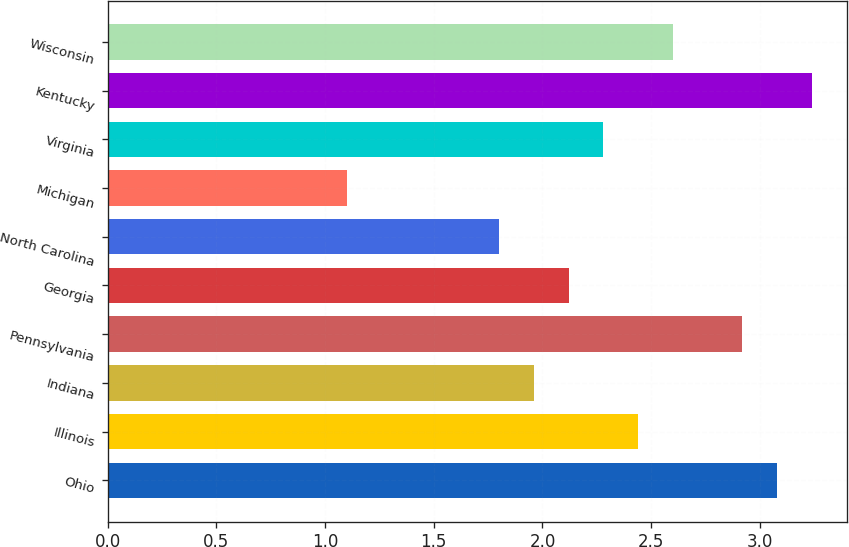<chart> <loc_0><loc_0><loc_500><loc_500><bar_chart><fcel>Ohio<fcel>Illinois<fcel>Indiana<fcel>Pennsylvania<fcel>Georgia<fcel>North Carolina<fcel>Michigan<fcel>Virginia<fcel>Kentucky<fcel>Wisconsin<nl><fcel>3.08<fcel>2.44<fcel>1.96<fcel>2.92<fcel>2.12<fcel>1.8<fcel>1.1<fcel>2.28<fcel>3.24<fcel>2.6<nl></chart> 